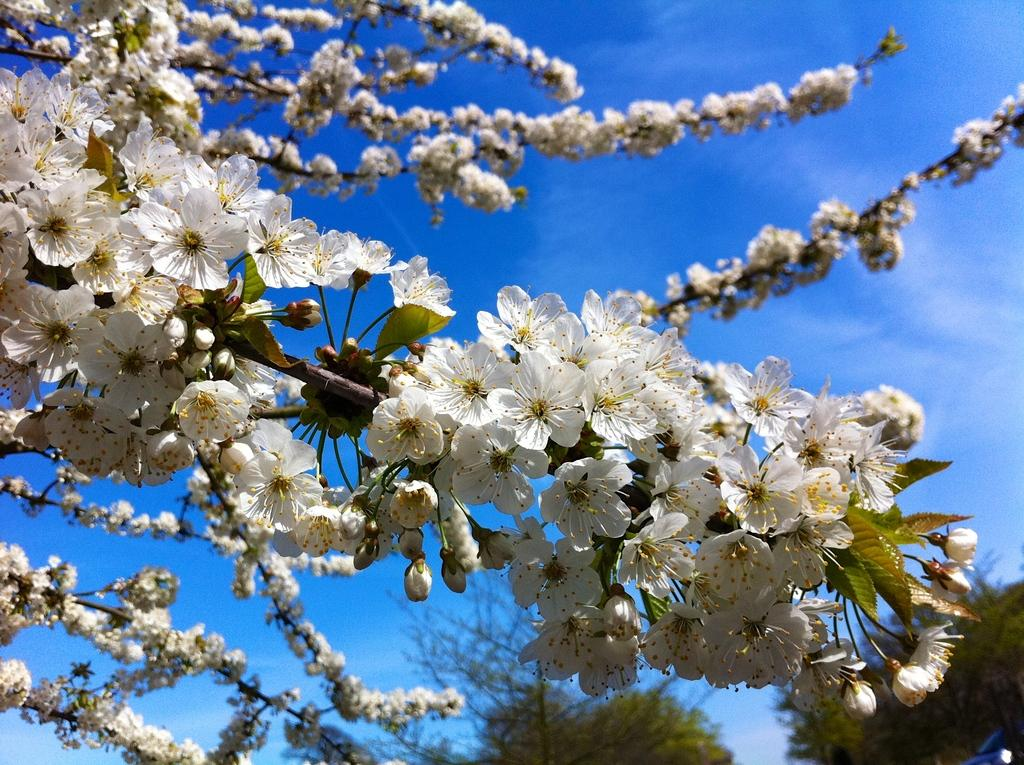What type of plants can be seen in the image? There are flowers in the image. What stage of growth are the flowers in? There are buds on the stems in the image. What other types of plants are visible in the image? There are trees in the image. What can be seen in the background of the image? The sky is visible in the image, and there are clouds in the sky. What color is the eye of the person in the image? There is no person present in the image, so there is no eye to observe. 